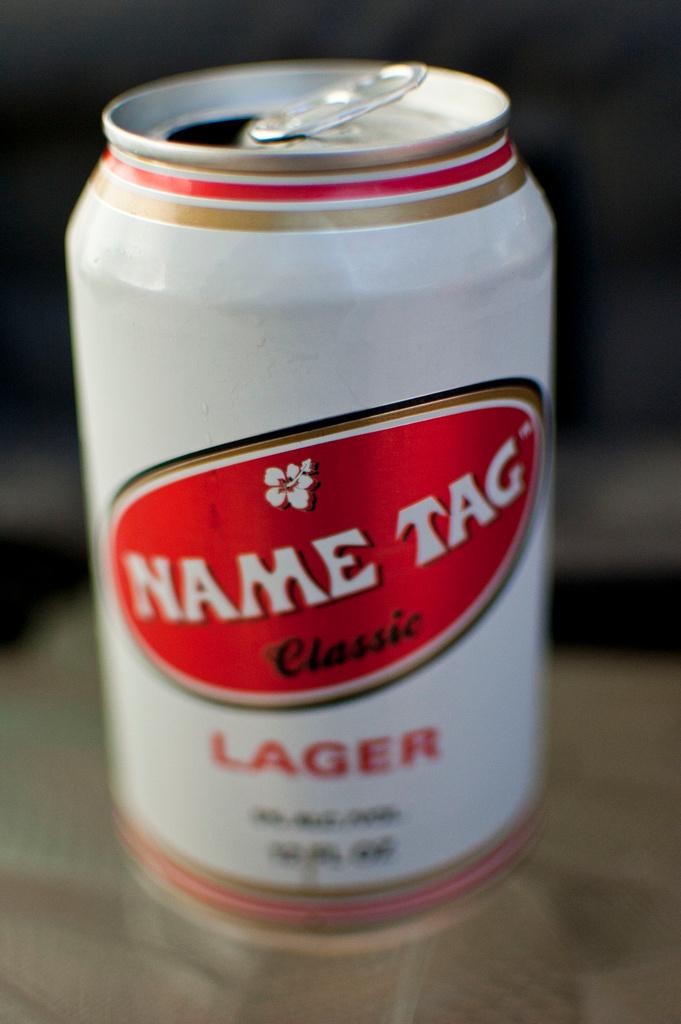What style of beer is in the can?
Offer a very short reply. Lager. What is the name of this beer?
Provide a succinct answer. Name tag. 